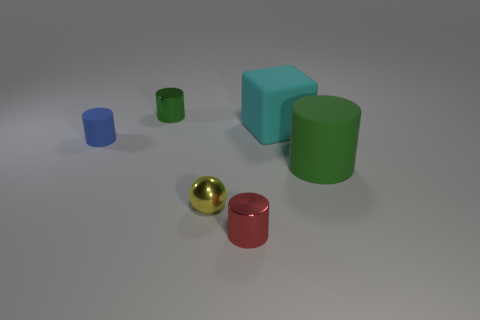The big thing left of the green cylinder in front of the shiny cylinder that is behind the yellow metal ball is made of what material?
Provide a succinct answer. Rubber. What size is the green object that is made of the same material as the tiny blue object?
Provide a succinct answer. Large. Is there anything else that has the same color as the cube?
Ensure brevity in your answer.  No. There is a metallic cylinder behind the shiny ball; does it have the same color as the small metallic cylinder that is to the right of the small shiny ball?
Provide a succinct answer. No. The large rubber thing that is on the right side of the cyan thing is what color?
Make the answer very short. Green. There is a green cylinder that is left of the green rubber thing; is its size the same as the big cylinder?
Offer a terse response. No. Is the number of tiny purple rubber objects less than the number of cylinders?
Your answer should be very brief. Yes. There is a small shiny thing that is the same color as the big rubber cylinder; what shape is it?
Your answer should be compact. Cylinder. What number of tiny metal objects are to the left of the red cylinder?
Your answer should be compact. 2. Is the cyan thing the same shape as the small yellow thing?
Ensure brevity in your answer.  No. 